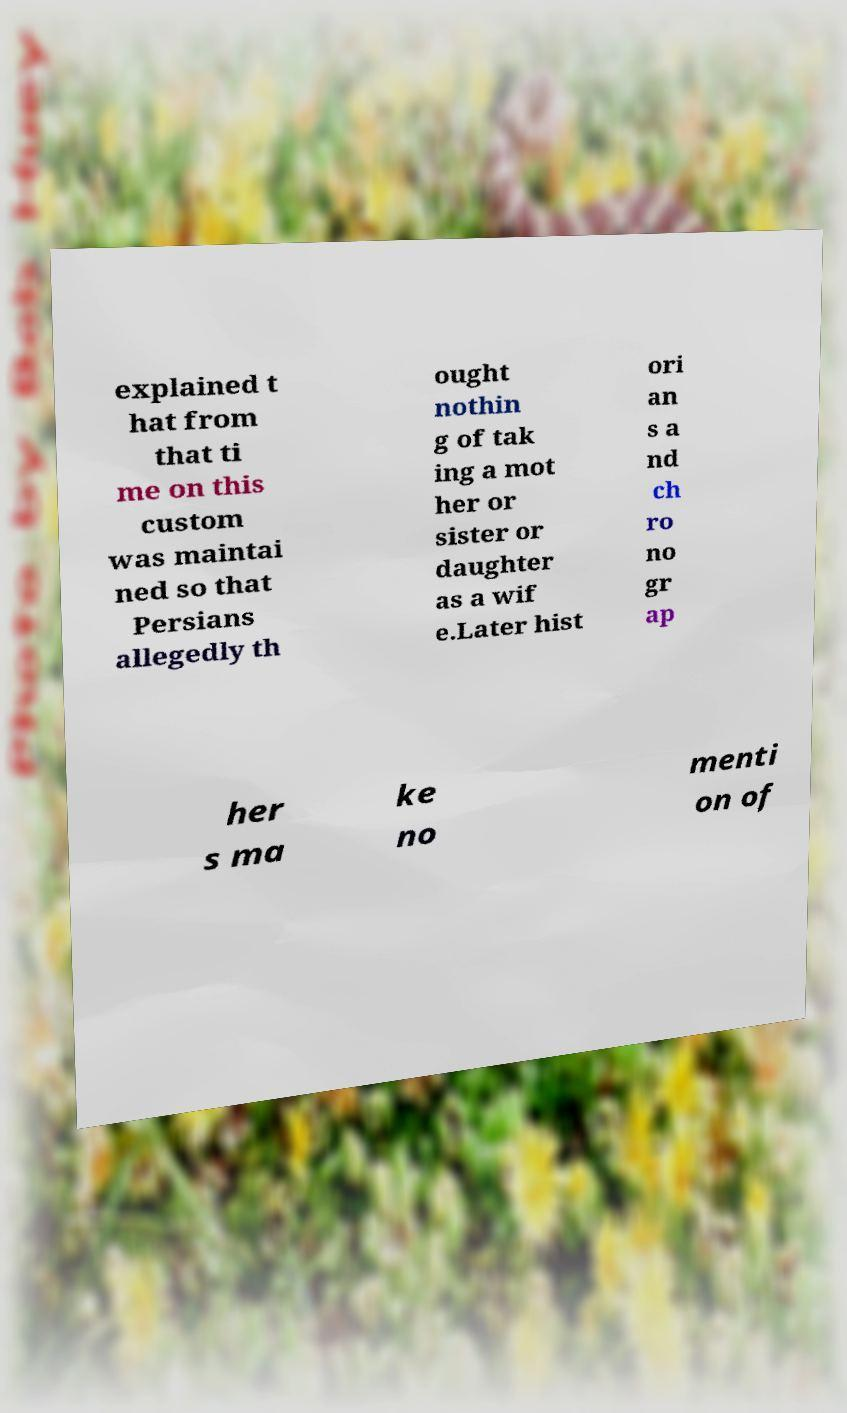There's text embedded in this image that I need extracted. Can you transcribe it verbatim? explained t hat from that ti me on this custom was maintai ned so that Persians allegedly th ought nothin g of tak ing a mot her or sister or daughter as a wif e.Later hist ori an s a nd ch ro no gr ap her s ma ke no menti on of 